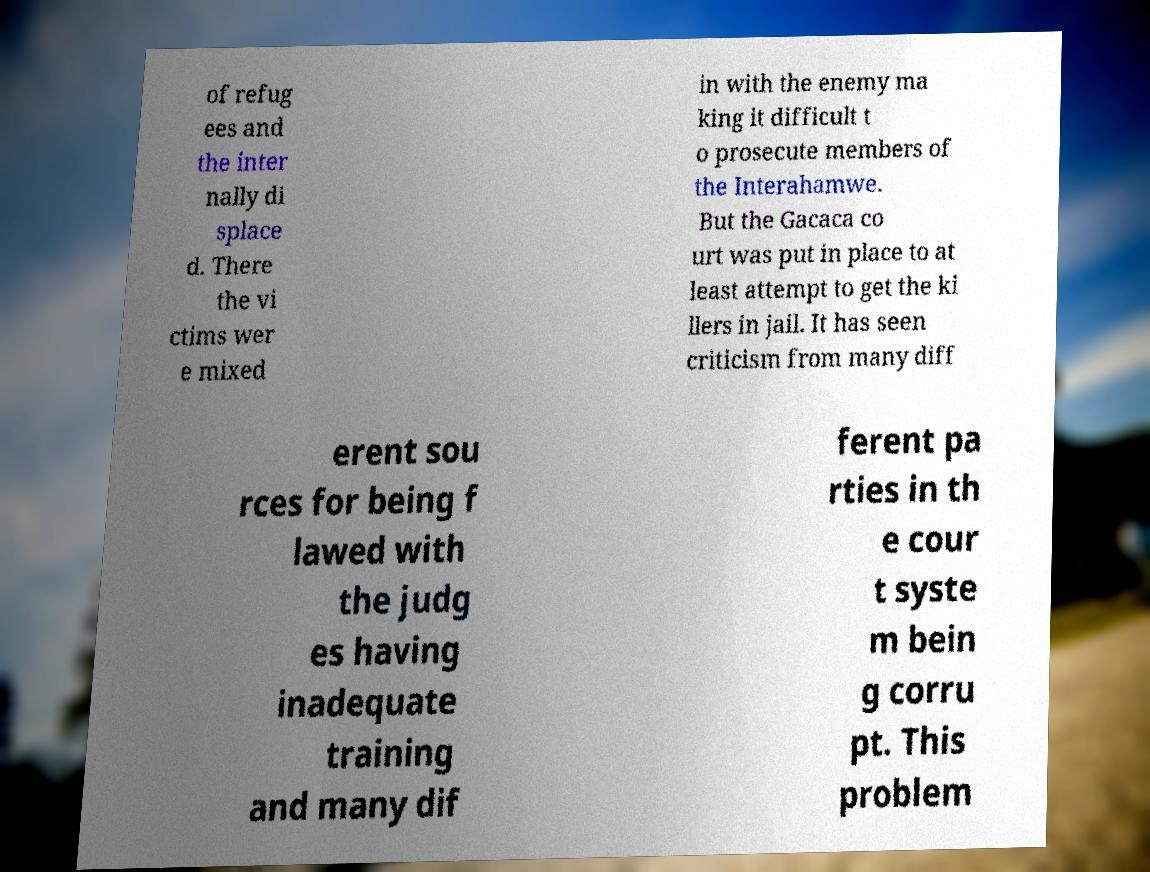Could you extract and type out the text from this image? of refug ees and the inter nally di splace d. There the vi ctims wer e mixed in with the enemy ma king it difficult t o prosecute members of the Interahamwe. But the Gacaca co urt was put in place to at least attempt to get the ki llers in jail. It has seen criticism from many diff erent sou rces for being f lawed with the judg es having inadequate training and many dif ferent pa rties in th e cour t syste m bein g corru pt. This problem 